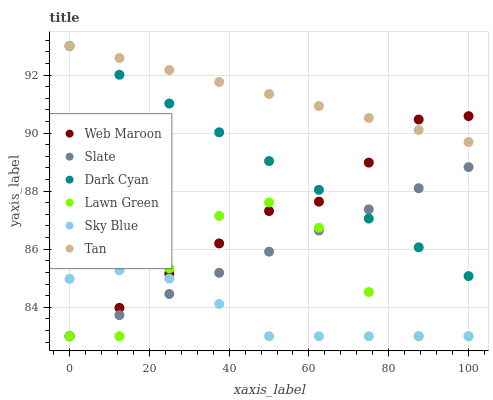Does Sky Blue have the minimum area under the curve?
Answer yes or no. Yes. Does Tan have the maximum area under the curve?
Answer yes or no. Yes. Does Slate have the minimum area under the curve?
Answer yes or no. No. Does Slate have the maximum area under the curve?
Answer yes or no. No. Is Slate the smoothest?
Answer yes or no. Yes. Is Lawn Green the roughest?
Answer yes or no. Yes. Is Web Maroon the smoothest?
Answer yes or no. No. Is Web Maroon the roughest?
Answer yes or no. No. Does Lawn Green have the lowest value?
Answer yes or no. Yes. Does Dark Cyan have the lowest value?
Answer yes or no. No. Does Tan have the highest value?
Answer yes or no. Yes. Does Slate have the highest value?
Answer yes or no. No. Is Lawn Green less than Dark Cyan?
Answer yes or no. Yes. Is Tan greater than Slate?
Answer yes or no. Yes. Does Slate intersect Sky Blue?
Answer yes or no. Yes. Is Slate less than Sky Blue?
Answer yes or no. No. Is Slate greater than Sky Blue?
Answer yes or no. No. Does Lawn Green intersect Dark Cyan?
Answer yes or no. No. 